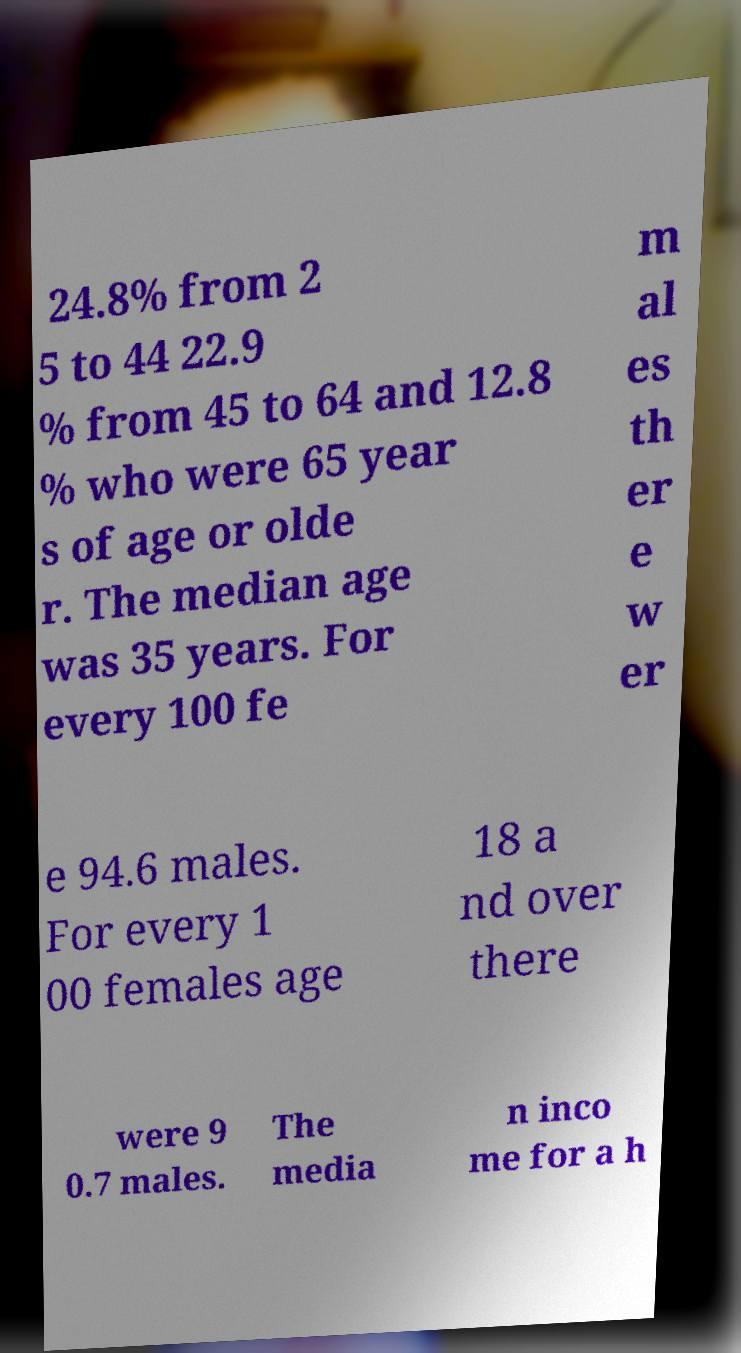Could you assist in decoding the text presented in this image and type it out clearly? 24.8% from 2 5 to 44 22.9 % from 45 to 64 and 12.8 % who were 65 year s of age or olde r. The median age was 35 years. For every 100 fe m al es th er e w er e 94.6 males. For every 1 00 females age 18 a nd over there were 9 0.7 males. The media n inco me for a h 